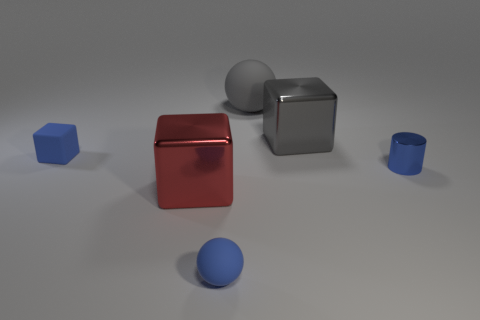Subtract all metal cubes. How many cubes are left? 1 Add 4 small things. How many objects exist? 10 Subtract all blue balls. How many balls are left? 1 Subtract all tiny blue objects. Subtract all gray spheres. How many objects are left? 2 Add 3 large gray metallic objects. How many large gray metallic objects are left? 4 Add 3 tiny gray balls. How many tiny gray balls exist? 3 Subtract 0 green cylinders. How many objects are left? 6 Subtract all cylinders. How many objects are left? 5 Subtract 1 cubes. How many cubes are left? 2 Subtract all purple blocks. Subtract all cyan spheres. How many blocks are left? 3 